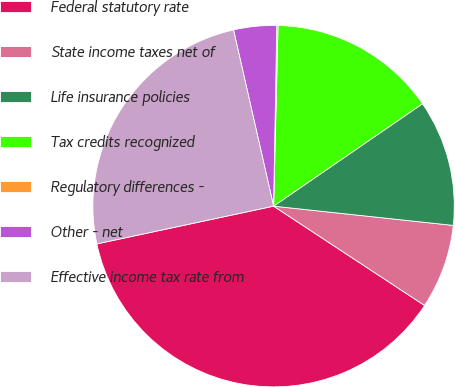Convert chart. <chart><loc_0><loc_0><loc_500><loc_500><pie_chart><fcel>Federal statutory rate<fcel>State income taxes net of<fcel>Life insurance policies<fcel>Tax credits recognized<fcel>Regulatory differences -<fcel>Other - net<fcel>Effective income tax rate from<nl><fcel>37.39%<fcel>7.56%<fcel>11.29%<fcel>15.02%<fcel>0.11%<fcel>3.84%<fcel>24.79%<nl></chart> 